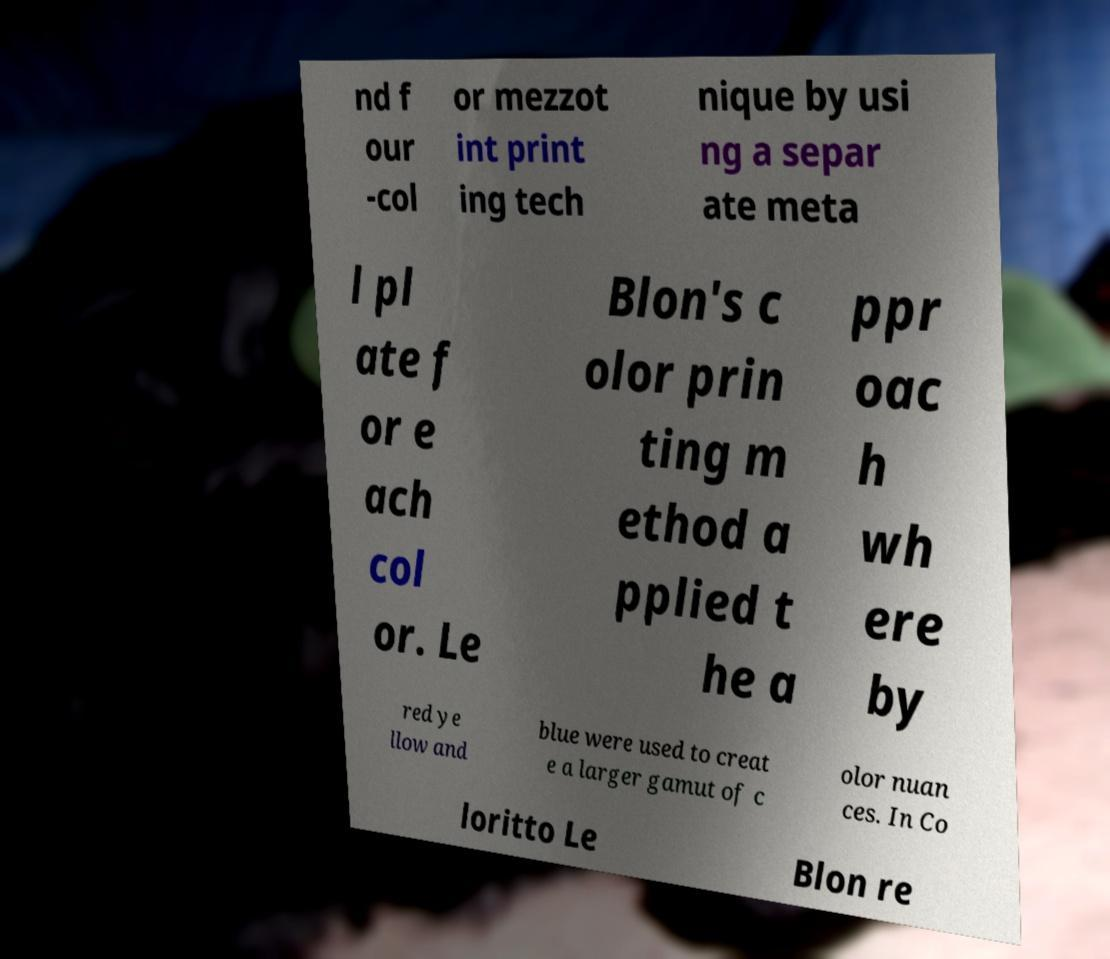Please identify and transcribe the text found in this image. nd f our -col or mezzot int print ing tech nique by usi ng a separ ate meta l pl ate f or e ach col or. Le Blon's c olor prin ting m ethod a pplied t he a ppr oac h wh ere by red ye llow and blue were used to creat e a larger gamut of c olor nuan ces. In Co loritto Le Blon re 